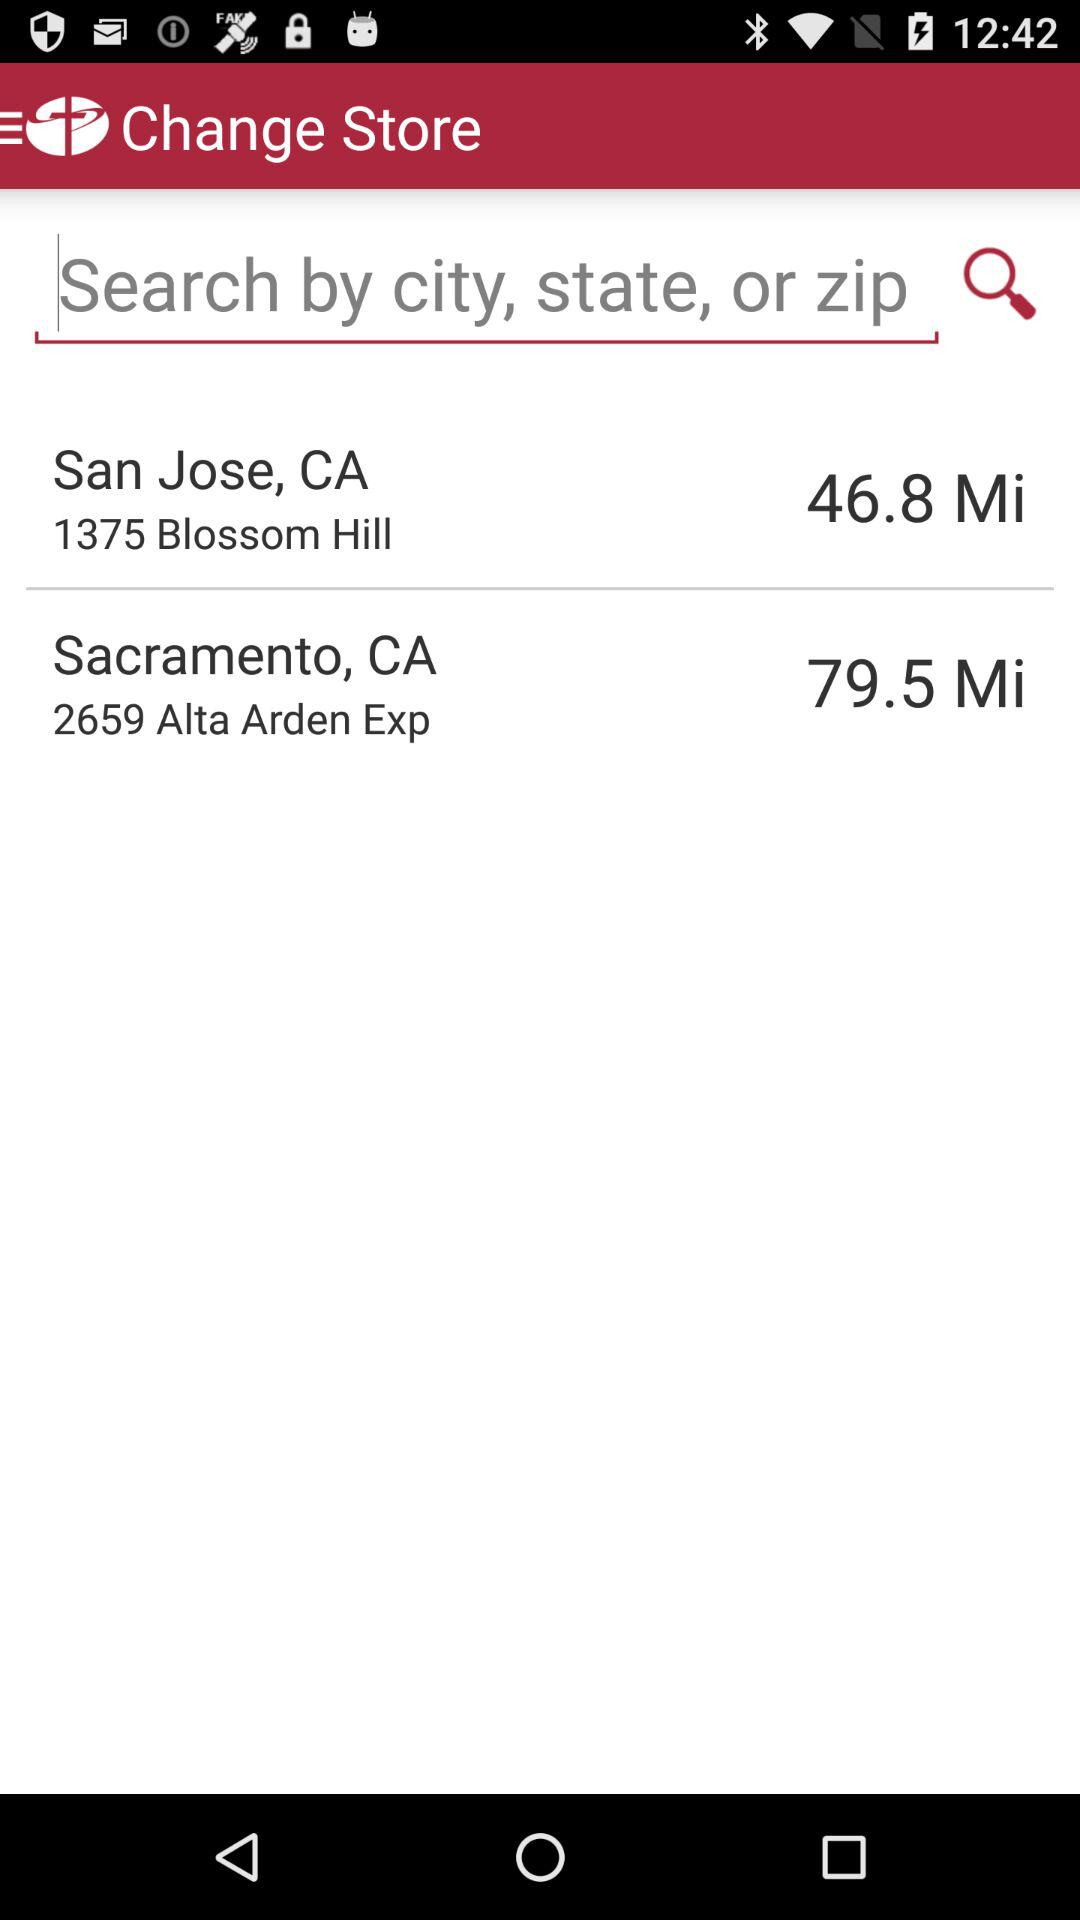Which store is further away, San Jose or Sacramento?
Answer the question using a single word or phrase. Sacramento 